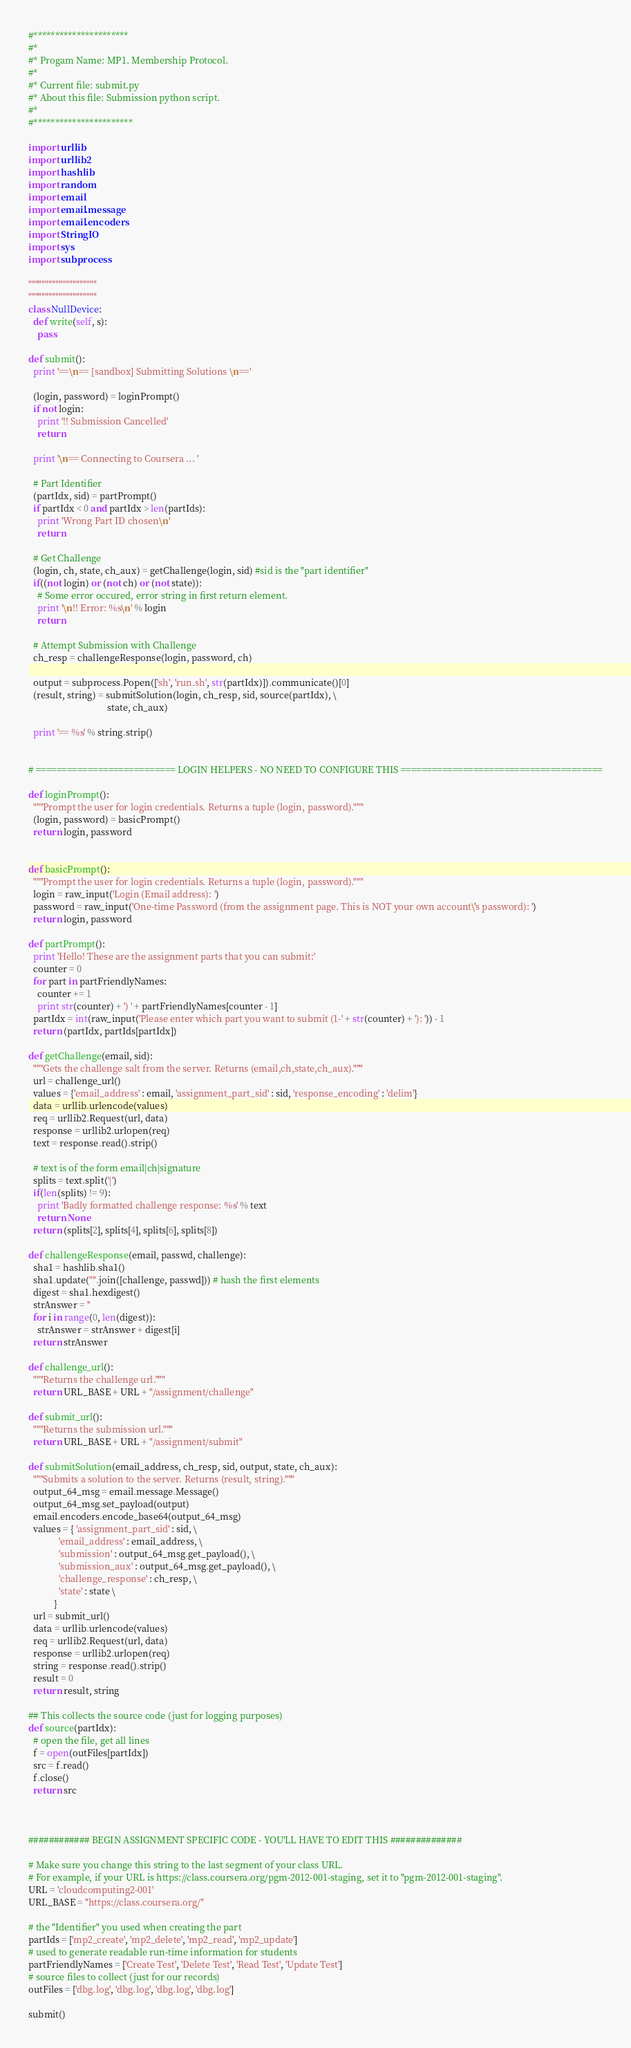Convert code to text. <code><loc_0><loc_0><loc_500><loc_500><_Python_>#**********************
#*
#* Progam Name: MP1. Membership Protocol.
#*
#* Current file: submit.py
#* About this file: Submission python script.
#* 
#***********************

import urllib
import urllib2
import hashlib
import random
import email
import email.message
import email.encoders
import StringIO
import sys
import subprocess

""""""""""""""""""""
""""""""""""""""""""
class NullDevice:
  def write(self, s):
    pass

def submit():   
  print '==\n== [sandbox] Submitting Solutions \n=='
  
  (login, password) = loginPrompt()
  if not login:
    print '!! Submission Cancelled'
    return
  
  print '\n== Connecting to Coursera ... '

  # Part Identifier
  (partIdx, sid) = partPrompt()
  if partIdx < 0 and partIdx > len(partIds):
	print 'Wrong Part ID chosen\n'
	return

  # Get Challenge
  (login, ch, state, ch_aux) = getChallenge(login, sid) #sid is the "part identifier"
  if((not login) or (not ch) or (not state)):
    # Some error occured, error string in first return element.
    print '\n!! Error: %s\n' % login
    return

  # Attempt Submission with Challenge
  ch_resp = challengeResponse(login, password, ch)

  output = subprocess.Popen(['sh', 'run.sh', str(partIdx)]).communicate()[0]
  (result, string) = submitSolution(login, ch_resp, sid, source(partIdx), \
                                  state, ch_aux)

  print '== %s' % string.strip()


# =========================== LOGIN HELPERS - NO NEED TO CONFIGURE THIS =======================================

def loginPrompt():
  """Prompt the user for login credentials. Returns a tuple (login, password)."""
  (login, password) = basicPrompt()
  return login, password


def basicPrompt():
  """Prompt the user for login credentials. Returns a tuple (login, password)."""
  login = raw_input('Login (Email address): ')
  password = raw_input('One-time Password (from the assignment page. This is NOT your own account\'s password): ')
  return login, password

def partPrompt():
  print 'Hello! These are the assignment parts that you can submit:'
  counter = 0
  for part in partFriendlyNames:
    counter += 1
    print str(counter) + ') ' + partFriendlyNames[counter - 1]
  partIdx = int(raw_input('Please enter which part you want to submit (1-' + str(counter) + '): ')) - 1
  return (partIdx, partIds[partIdx])

def getChallenge(email, sid):
  """Gets the challenge salt from the server. Returns (email,ch,state,ch_aux)."""
  url = challenge_url()
  values = {'email_address' : email, 'assignment_part_sid' : sid, 'response_encoding' : 'delim'}
  data = urllib.urlencode(values)
  req = urllib2.Request(url, data)
  response = urllib2.urlopen(req)
  text = response.read().strip()

  # text is of the form email|ch|signature
  splits = text.split('|')
  if(len(splits) != 9):
    print 'Badly formatted challenge response: %s' % text
    return None
  return (splits[2], splits[4], splits[6], splits[8])

def challengeResponse(email, passwd, challenge):
  sha1 = hashlib.sha1()
  sha1.update("".join([challenge, passwd])) # hash the first elements
  digest = sha1.hexdigest()
  strAnswer = ''
  for i in range(0, len(digest)):
    strAnswer = strAnswer + digest[i]
  return strAnswer 
  
def challenge_url():
  """Returns the challenge url."""
  return URL_BASE + URL + "/assignment/challenge"

def submit_url():
  """Returns the submission url."""
  return URL_BASE + URL + "/assignment/submit"

def submitSolution(email_address, ch_resp, sid, output, state, ch_aux):
  """Submits a solution to the server. Returns (result, string)."""
  output_64_msg = email.message.Message()
  output_64_msg.set_payload(output)
  email.encoders.encode_base64(output_64_msg)
  values = { 'assignment_part_sid' : sid, \
             'email_address' : email_address, \
             'submission' : output_64_msg.get_payload(), \
             'submission_aux' : output_64_msg.get_payload(), \
             'challenge_response' : ch_resp, \
             'state' : state \
           }
  url = submit_url()
  data = urllib.urlencode(values)
  req = urllib2.Request(url, data)
  response = urllib2.urlopen(req)
  string = response.read().strip()
  result = 0
  return result, string

## This collects the source code (just for logging purposes) 
def source(partIdx):
  # open the file, get all lines
  f = open(outFiles[partIdx])
  src = f.read() 
  f.close()
  return src



############ BEGIN ASSIGNMENT SPECIFIC CODE - YOU'LL HAVE TO EDIT THIS ##############

# Make sure you change this string to the last segment of your class URL.
# For example, if your URL is https://class.coursera.org/pgm-2012-001-staging, set it to "pgm-2012-001-staging".
URL = 'cloudcomputing2-001'
URL_BASE = "https://class.coursera.org/"

# the "Identifier" you used when creating the part
partIds = ['mp2_create', 'mp2_delete', 'mp2_read', 'mp2_update']
# used to generate readable run-time information for students
partFriendlyNames = ['Create Test', 'Delete Test', 'Read Test', 'Update Test'] 
# source files to collect (just for our records)
outFiles = ['dbg.log', 'dbg.log', 'dbg.log', 'dbg.log'] 

submit()

</code> 